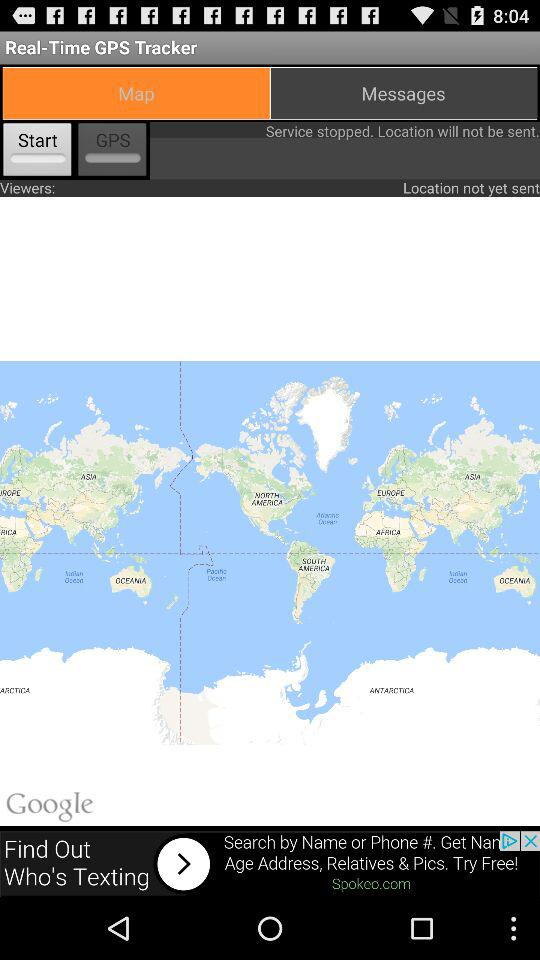How many viewers are there?
Answer the question using a single word or phrase. 0 